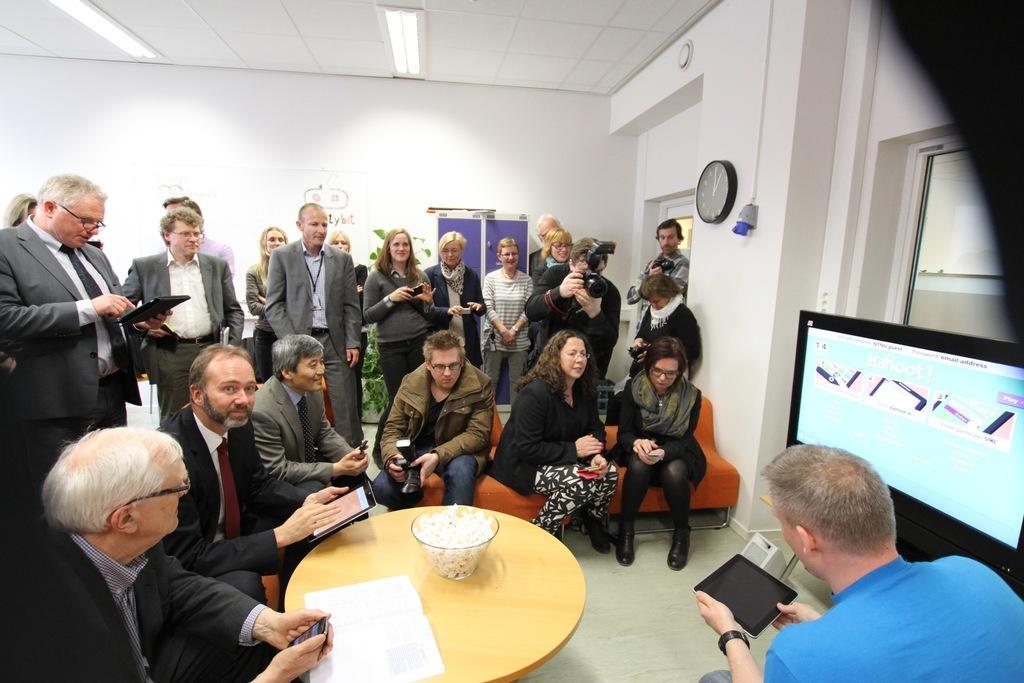Describe this image in one or two sentences. A group of people are watching at a screen,presented by a man beside it. 